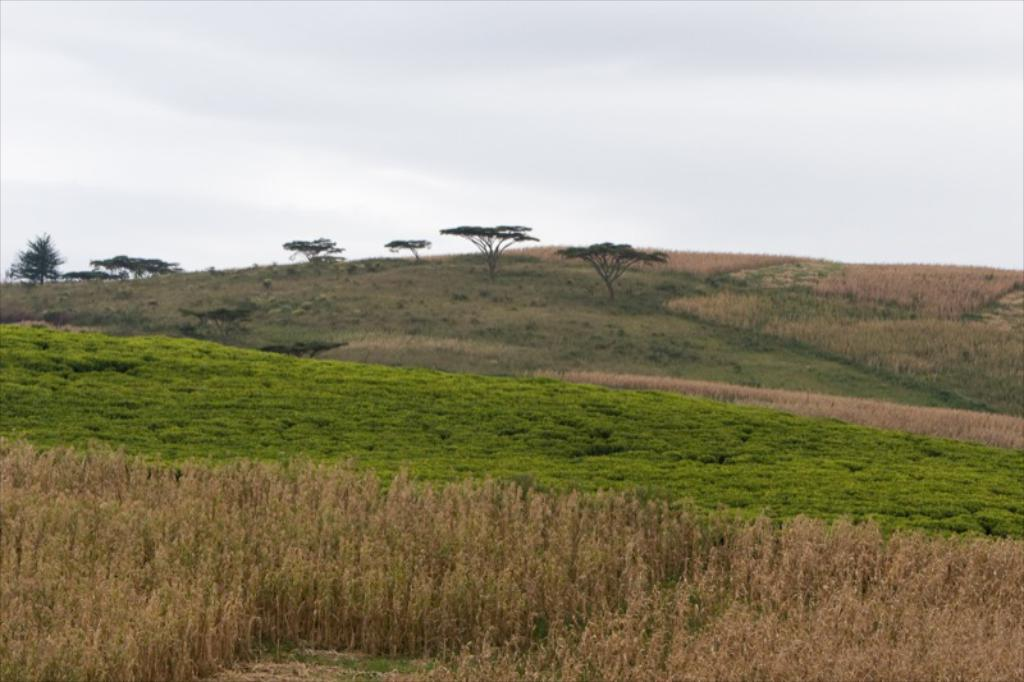What type of landscape is depicted in the image? There is farmland in the image. What can be seen at the bottom of the image? There are plants and grass at the bottom of the image. What is visible in the background of the image? There is a mountain and trees in the background of the image. What is visible at the top of the image? The sky is visible at the top of the image. What can be observed in the sky? Clouds are present in the sky. How many pages of a book can be seen in the image? There are no pages of a book present in the image. What type of glass objects can be seen in the image? There are no glass objects present in the image. 